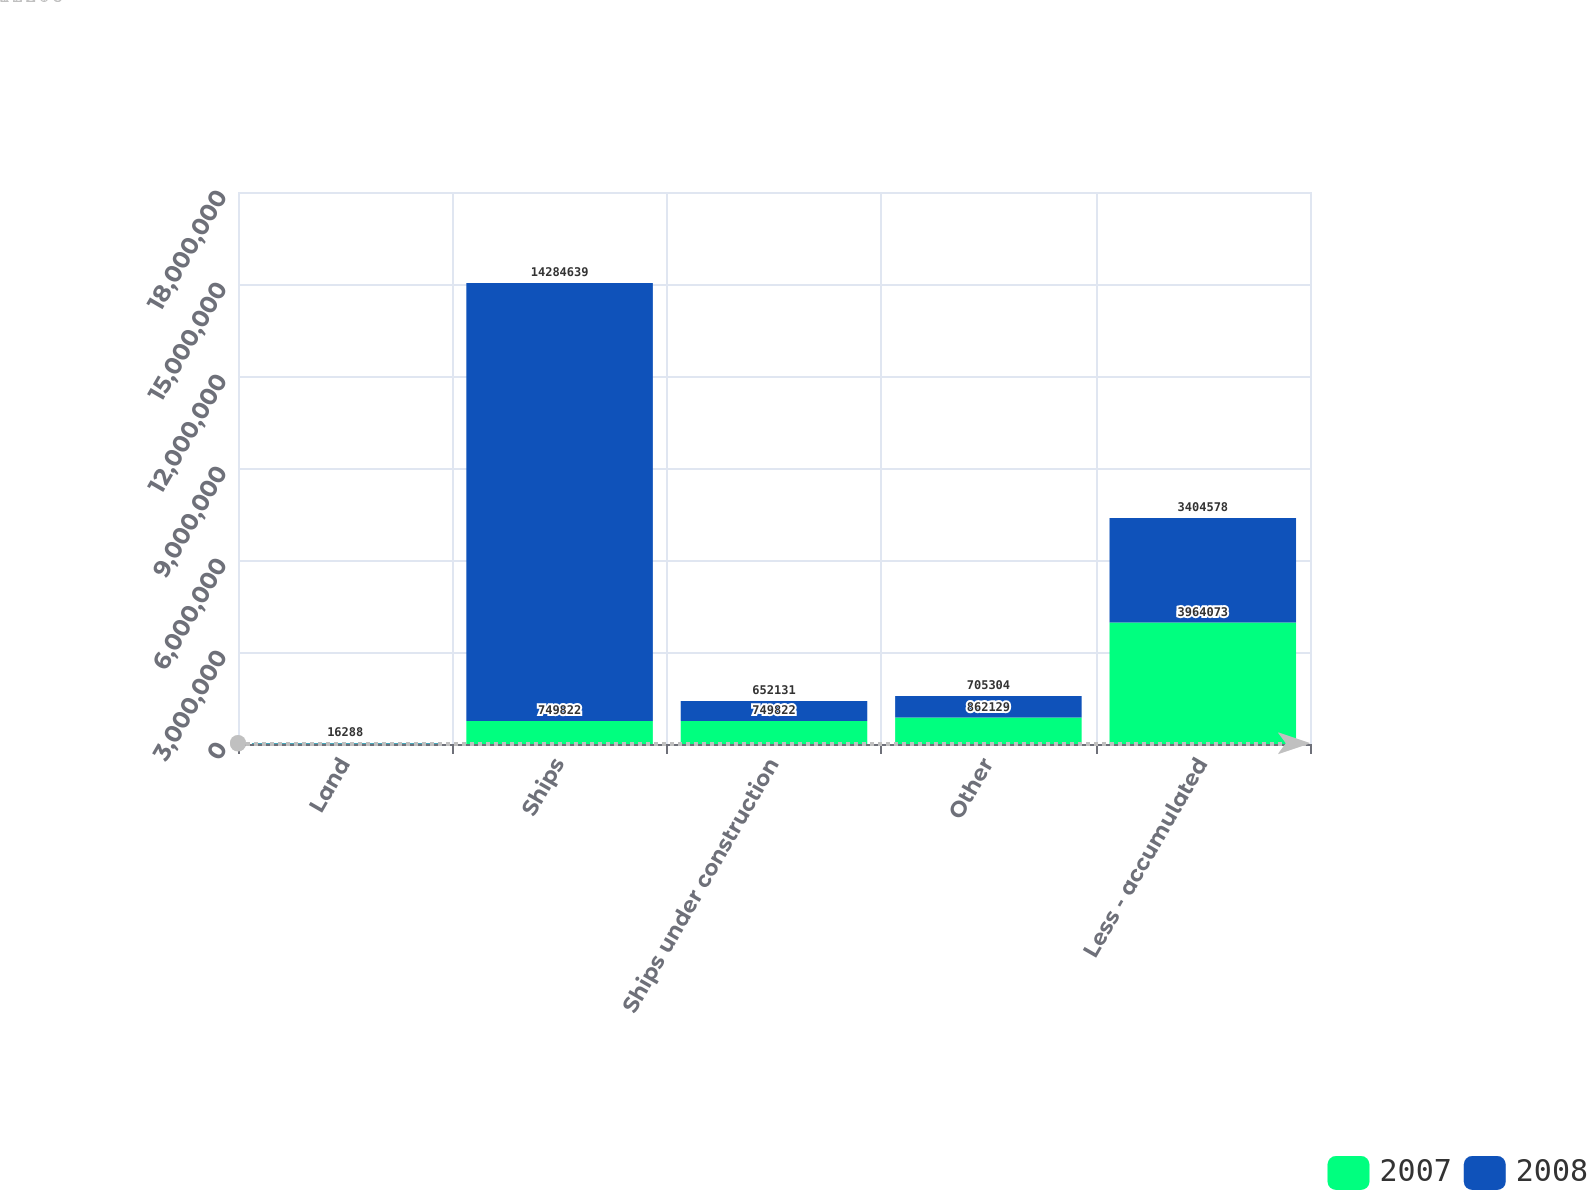Convert chart to OTSL. <chart><loc_0><loc_0><loc_500><loc_500><stacked_bar_chart><ecel><fcel>Land<fcel>Ships<fcel>Ships under construction<fcel>Other<fcel>Less - accumulated<nl><fcel>2007<fcel>16288<fcel>749822<fcel>749822<fcel>862129<fcel>3.96407e+06<nl><fcel>2008<fcel>16288<fcel>1.42846e+07<fcel>652131<fcel>705304<fcel>3.40458e+06<nl></chart> 